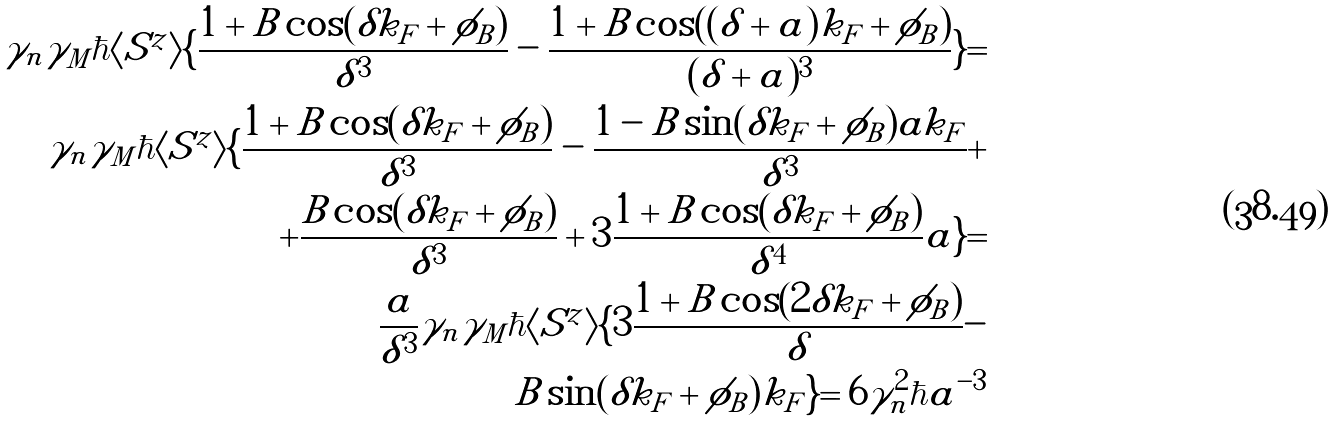Convert formula to latex. <formula><loc_0><loc_0><loc_500><loc_500>\gamma _ { n } \gamma _ { M } \hbar { \langle } S ^ { z } \rangle \{ \frac { 1 + B \cos ( \delta k _ { F } + \phi _ { B } ) } { \delta ^ { 3 } } - \frac { 1 + B \cos ( ( \delta + a ) k _ { F } + \phi _ { B } ) } { ( \delta + a ) ^ { 3 } } \} = \\ \gamma _ { n } \gamma _ { M } \hbar { \langle } S ^ { z } \rangle \{ \frac { 1 + B \cos ( \delta k _ { F } + \phi _ { B } ) } { \delta ^ { 3 } } - \frac { 1 - B \sin ( \delta k _ { F } + \phi _ { B } ) a k _ { F } } { \delta ^ { 3 } } + \\ + \frac { B \cos ( \delta k _ { F } + \phi _ { B } ) } { \delta ^ { 3 } } + 3 \frac { 1 + B \cos ( \delta k _ { F } + \phi _ { B } ) } { \delta ^ { 4 } } a \} = \\ \frac { a } { \delta ^ { 3 } } \gamma _ { n } \gamma _ { M } \hbar { \langle } S ^ { z } \rangle \{ 3 \frac { 1 + B \cos ( 2 \delta k _ { F } + \phi _ { B } ) } { \delta } - \\ B \sin ( \delta k _ { F } + \phi _ { B } ) k _ { F } \} = 6 \gamma _ { n } ^ { 2 } \hbar { a } ^ { - 3 }</formula> 